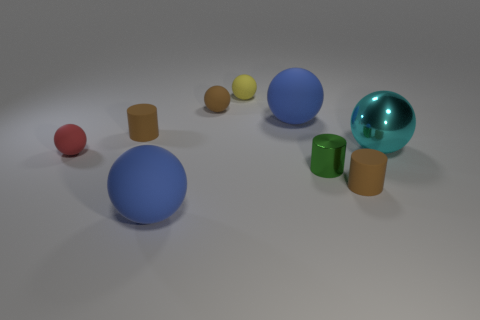Subtract all small brown cylinders. How many cylinders are left? 1 Subtract 3 spheres. How many spheres are left? 3 Subtract all balls. How many objects are left? 3 Subtract 0 blue cubes. How many objects are left? 9 Subtract all yellow balls. Subtract all yellow cylinders. How many balls are left? 5 Subtract all purple cylinders. How many cyan balls are left? 1 Subtract all green shiny cylinders. Subtract all tiny gray matte spheres. How many objects are left? 8 Add 7 green metal cylinders. How many green metal cylinders are left? 8 Add 5 brown rubber spheres. How many brown rubber spheres exist? 6 Add 1 red rubber objects. How many objects exist? 10 